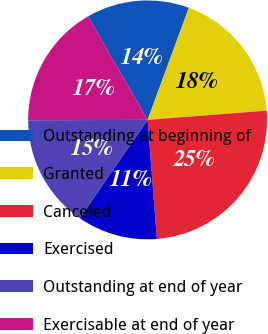Convert chart. <chart><loc_0><loc_0><loc_500><loc_500><pie_chart><fcel>Outstanding at beginning of<fcel>Granted<fcel>Canceled<fcel>Exercised<fcel>Outstanding at end of year<fcel>Exercisable at end of year<nl><fcel>13.92%<fcel>18.15%<fcel>24.99%<fcel>10.86%<fcel>15.33%<fcel>16.74%<nl></chart> 